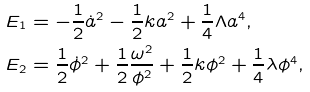<formula> <loc_0><loc_0><loc_500><loc_500>E _ { 1 } & = - \frac { 1 } { 2 } \dot { a } ^ { 2 } - \frac { 1 } { 2 } k a ^ { 2 } + \frac { 1 } { 4 } \Lambda a ^ { 4 } , \\ E _ { 2 } & = \frac { 1 } { 2 } \dot { \phi } ^ { 2 } + \frac { 1 } { 2 } \frac { \omega ^ { 2 } } { \phi ^ { 2 } } + \frac { 1 } { 2 } k \phi ^ { 2 } + \frac { 1 } { 4 } \lambda \phi ^ { 4 } ,</formula> 